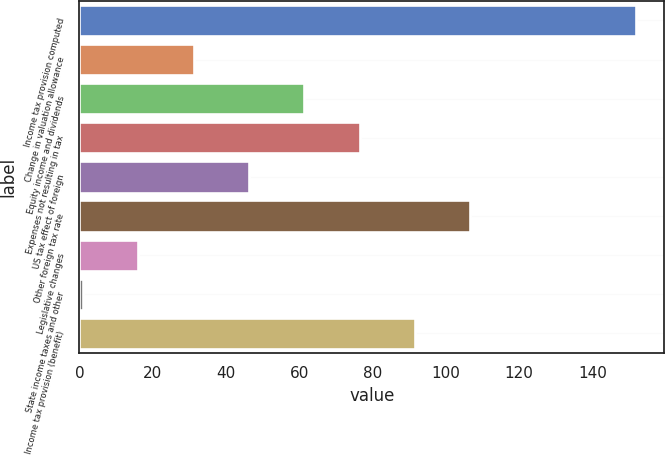<chart> <loc_0><loc_0><loc_500><loc_500><bar_chart><fcel>Income tax provision computed<fcel>Change in valuation allowance<fcel>Equity income and dividends<fcel>Expenses not resulting in tax<fcel>US tax effect of foreign<fcel>Other foreign tax rate<fcel>Legislative changes<fcel>State income taxes and other<fcel>Income tax provision (benefit)<nl><fcel>152<fcel>31.2<fcel>61.4<fcel>76.5<fcel>46.3<fcel>106.7<fcel>16.1<fcel>1<fcel>91.6<nl></chart> 